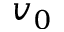<formula> <loc_0><loc_0><loc_500><loc_500>v _ { 0 }</formula> 